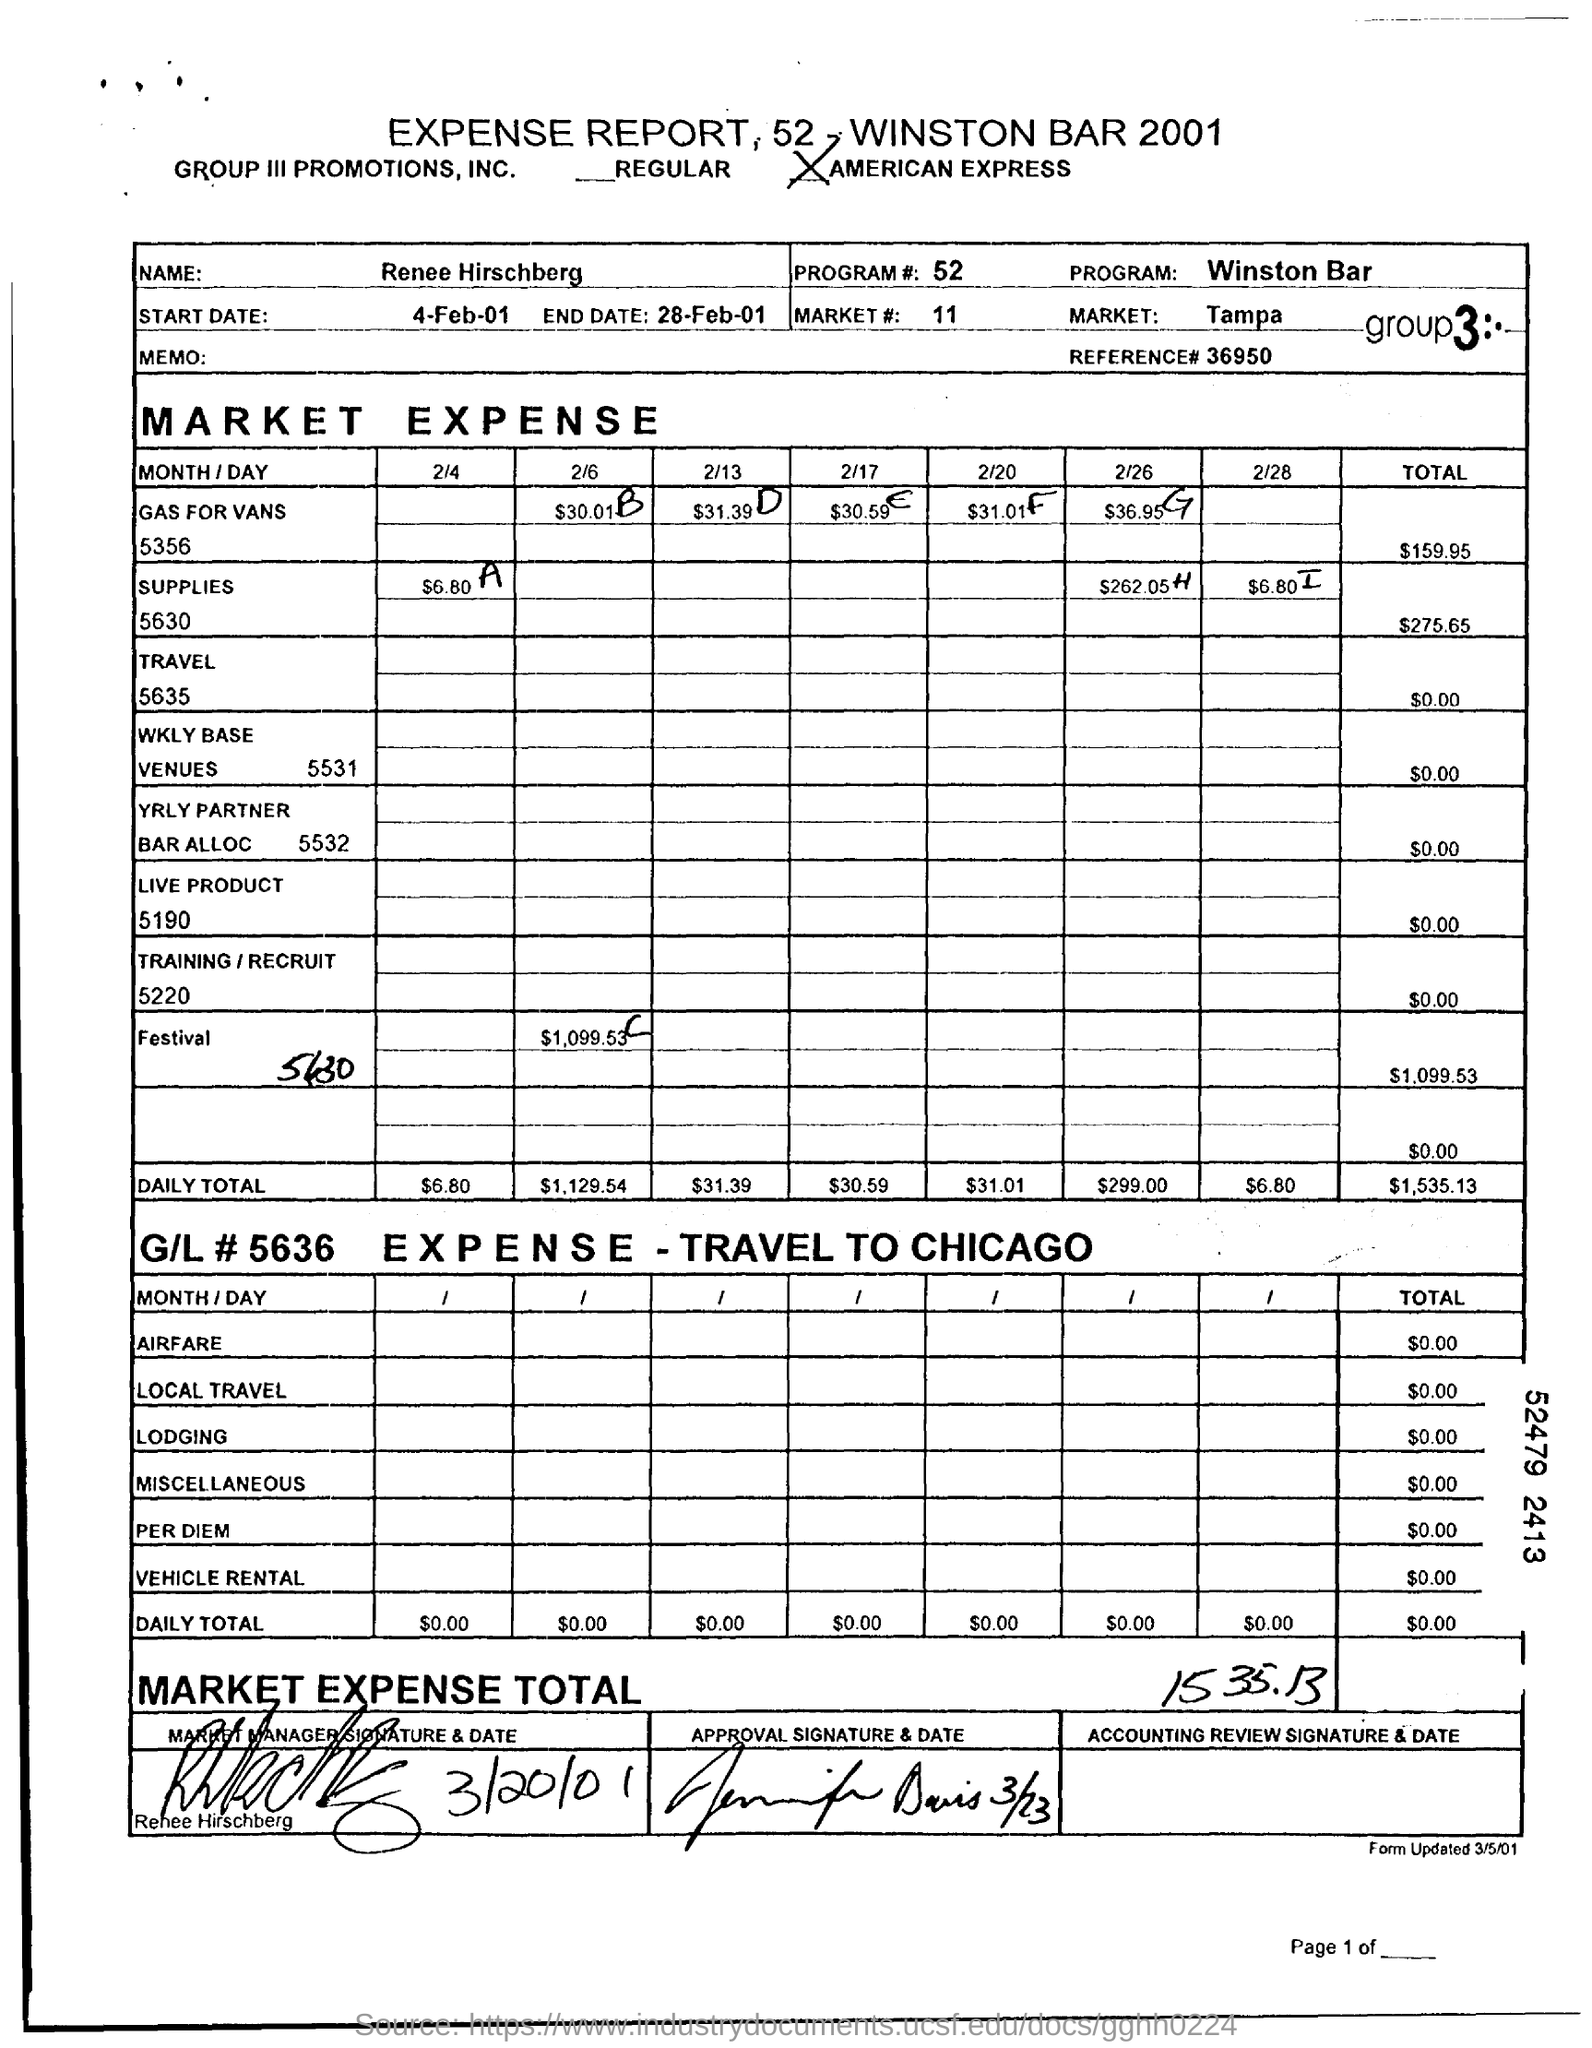Outline some significant characteristics in this image. The total expense for supplies was $275.65. What is the program number mentioned on the expense report? The start date mentioned in the report is April 4th, 2001. The market expense for the festival was $1,099.53. The total expense mentioned in the expense report is 1535.13. 